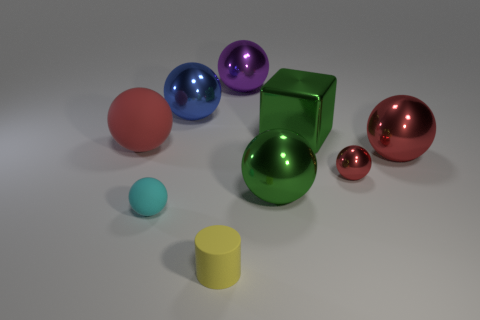Subtract all large blue balls. How many balls are left? 6 Subtract all green spheres. How many spheres are left? 6 Subtract 1 cylinders. How many cylinders are left? 0 Subtract all red spheres. Subtract all brown cubes. How many spheres are left? 4 Subtract 1 yellow cylinders. How many objects are left? 8 Subtract all cylinders. How many objects are left? 8 Subtract all red spheres. How many red blocks are left? 0 Subtract all green cylinders. Subtract all small cyan matte things. How many objects are left? 8 Add 8 large rubber objects. How many large rubber objects are left? 9 Add 1 tiny cyan matte balls. How many tiny cyan matte balls exist? 2 